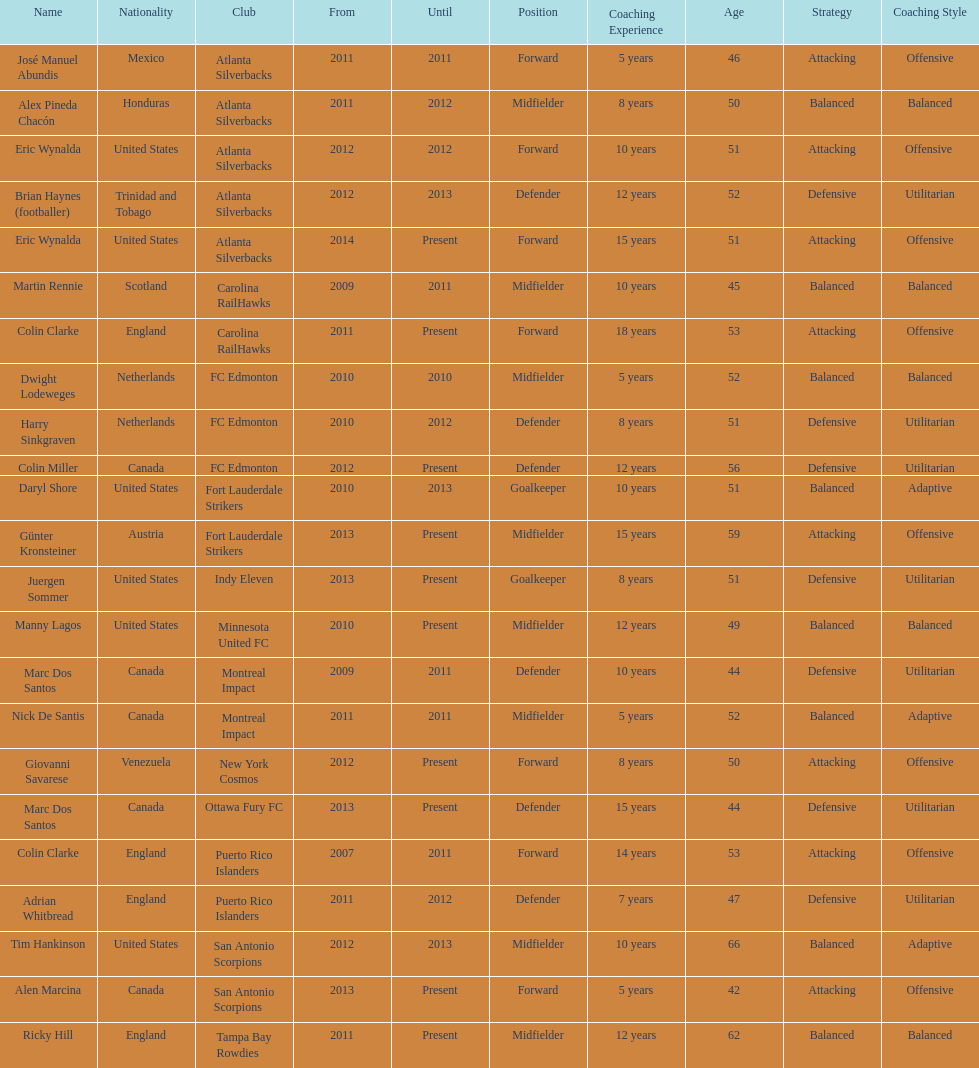I'm looking to parse the entire table for insights. Could you assist me with that? {'header': ['Name', 'Nationality', 'Club', 'From', 'Until', 'Position', 'Coaching Experience', 'Age', 'Strategy', 'Coaching Style'], 'rows': [['José Manuel Abundis', 'Mexico', 'Atlanta Silverbacks', '2011', '2011', 'Forward', '5 years', '46', 'Attacking', 'Offensive'], ['Alex Pineda Chacón', 'Honduras', 'Atlanta Silverbacks', '2011', '2012', 'Midfielder', '8 years', '50', 'Balanced', 'Balanced'], ['Eric Wynalda', 'United States', 'Atlanta Silverbacks', '2012', '2012', 'Forward', '10 years', '51', 'Attacking', 'Offensive '], ['Brian Haynes (footballer)', 'Trinidad and Tobago', 'Atlanta Silverbacks', '2012', '2013', 'Defender', '12 years', '52', 'Defensive', 'Utilitarian'], ['Eric Wynalda', 'United States', 'Atlanta Silverbacks', '2014', 'Present', 'Forward', '15 years', '51', 'Attacking', 'Offensive'], ['Martin Rennie', 'Scotland', 'Carolina RailHawks', '2009', '2011', 'Midfielder', '10 years', '45', 'Balanced', 'Balanced'], ['Colin Clarke', 'England', 'Carolina RailHawks', '2011', 'Present', 'Forward', '18 years', '53', 'Attacking', 'Offensive'], ['Dwight Lodeweges', 'Netherlands', 'FC Edmonton', '2010', '2010', 'Midfielder', '5 years', '52', 'Balanced', 'Balanced'], ['Harry Sinkgraven', 'Netherlands', 'FC Edmonton', '2010', '2012', 'Defender', '8 years', '51', 'Defensive', 'Utilitarian'], ['Colin Miller', 'Canada', 'FC Edmonton', '2012', 'Present', 'Defender', '12 years', '56', 'Defensive', 'Utilitarian'], ['Daryl Shore', 'United States', 'Fort Lauderdale Strikers', '2010', '2013', 'Goalkeeper', '10 years', '51', 'Balanced', 'Adaptive'], ['Günter Kronsteiner', 'Austria', 'Fort Lauderdale Strikers', '2013', 'Present', 'Midfielder', '15 years', '59', 'Attacking', 'Offensive'], ['Juergen Sommer', 'United States', 'Indy Eleven', '2013', 'Present', 'Goalkeeper', '8 years', '51', 'Defensive', 'Utilitarian'], ['Manny Lagos', 'United States', 'Minnesota United FC', '2010', 'Present', 'Midfielder', '12 years', '49', 'Balanced', 'Balanced'], ['Marc Dos Santos', 'Canada', 'Montreal Impact', '2009', '2011', 'Defender', '10 years', '44', 'Defensive', 'Utilitarian'], ['Nick De Santis', 'Canada', 'Montreal Impact', '2011', '2011', 'Midfielder', '5 years', '52', 'Balanced', 'Adaptive'], ['Giovanni Savarese', 'Venezuela', 'New York Cosmos', '2012', 'Present', 'Forward', '8 years', '50', 'Attacking', 'Offensive'], ['Marc Dos Santos', 'Canada', 'Ottawa Fury FC', '2013', 'Present', 'Defender', '15 years', '44', 'Defensive', 'Utilitarian'], ['Colin Clarke', 'England', 'Puerto Rico Islanders', '2007', '2011', 'Forward', '14 years', '53', 'Attacking', 'Offensive'], ['Adrian Whitbread', 'England', 'Puerto Rico Islanders', '2011', '2012', 'Defender', '7 years', '47', 'Defensive', 'Utilitarian'], ['Tim Hankinson', 'United States', 'San Antonio Scorpions', '2012', '2013', 'Midfielder', '10 years', '66', 'Balanced', 'Adaptive'], ['Alen Marcina', 'Canada', 'San Antonio Scorpions', '2013', 'Present', 'Forward', '5 years', '42', 'Attacking', 'Offensive'], ['Ricky Hill', 'England', 'Tampa Bay Rowdies', '2011', 'Present', 'Midfielder', '12 years', '62', 'Balanced', 'Balanced']]} How long did colin clarke coach the puerto rico islanders for? 4 years. 